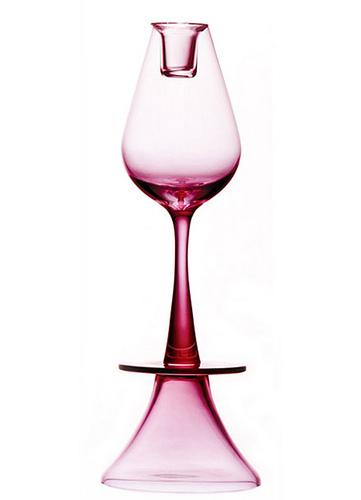How many different examples of liquor glassware are built into this?
Answer briefly. 3. Would this break if dropped on concrete?
Keep it brief. Yes. Is this one piece?
Be succinct. Yes. 